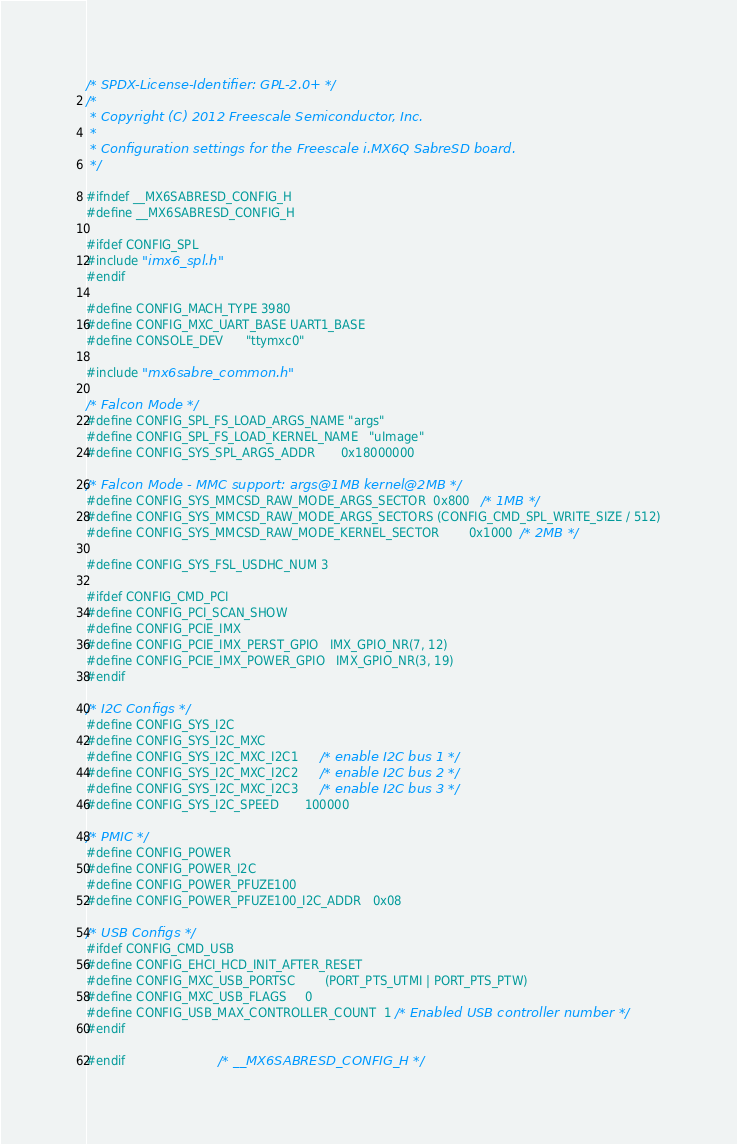Convert code to text. <code><loc_0><loc_0><loc_500><loc_500><_C_>/* SPDX-License-Identifier: GPL-2.0+ */
/*
 * Copyright (C) 2012 Freescale Semiconductor, Inc.
 *
 * Configuration settings for the Freescale i.MX6Q SabreSD board.
 */

#ifndef __MX6SABRESD_CONFIG_H
#define __MX6SABRESD_CONFIG_H

#ifdef CONFIG_SPL
#include "imx6_spl.h"
#endif

#define CONFIG_MACH_TYPE	3980
#define CONFIG_MXC_UART_BASE	UART1_BASE
#define CONSOLE_DEV		"ttymxc0"

#include "mx6sabre_common.h"

/* Falcon Mode */
#define CONFIG_SPL_FS_LOAD_ARGS_NAME	"args"
#define CONFIG_SPL_FS_LOAD_KERNEL_NAME	"uImage"
#define CONFIG_SYS_SPL_ARGS_ADDR       0x18000000

/* Falcon Mode - MMC support: args@1MB kernel@2MB */
#define CONFIG_SYS_MMCSD_RAW_MODE_ARGS_SECTOR  0x800   /* 1MB */
#define CONFIG_SYS_MMCSD_RAW_MODE_ARGS_SECTORS (CONFIG_CMD_SPL_WRITE_SIZE / 512)
#define CONFIG_SYS_MMCSD_RAW_MODE_KERNEL_SECTOR        0x1000  /* 2MB */

#define CONFIG_SYS_FSL_USDHC_NUM	3

#ifdef CONFIG_CMD_PCI
#define CONFIG_PCI_SCAN_SHOW
#define CONFIG_PCIE_IMX
#define CONFIG_PCIE_IMX_PERST_GPIO	IMX_GPIO_NR(7, 12)
#define CONFIG_PCIE_IMX_POWER_GPIO	IMX_GPIO_NR(3, 19)
#endif

/* I2C Configs */
#define CONFIG_SYS_I2C
#define CONFIG_SYS_I2C_MXC
#define CONFIG_SYS_I2C_MXC_I2C1		/* enable I2C bus 1 */
#define CONFIG_SYS_I2C_MXC_I2C2		/* enable I2C bus 2 */
#define CONFIG_SYS_I2C_MXC_I2C3		/* enable I2C bus 3 */
#define CONFIG_SYS_I2C_SPEED		  100000

/* PMIC */
#define CONFIG_POWER
#define CONFIG_POWER_I2C
#define CONFIG_POWER_PFUZE100
#define CONFIG_POWER_PFUZE100_I2C_ADDR	0x08

/* USB Configs */
#ifdef CONFIG_CMD_USB
#define CONFIG_EHCI_HCD_INIT_AFTER_RESET
#define CONFIG_MXC_USB_PORTSC		(PORT_PTS_UTMI | PORT_PTS_PTW)
#define CONFIG_MXC_USB_FLAGS		0
#define CONFIG_USB_MAX_CONTROLLER_COUNT	1 /* Enabled USB controller number */
#endif

#endif                         /* __MX6SABRESD_CONFIG_H */
</code> 